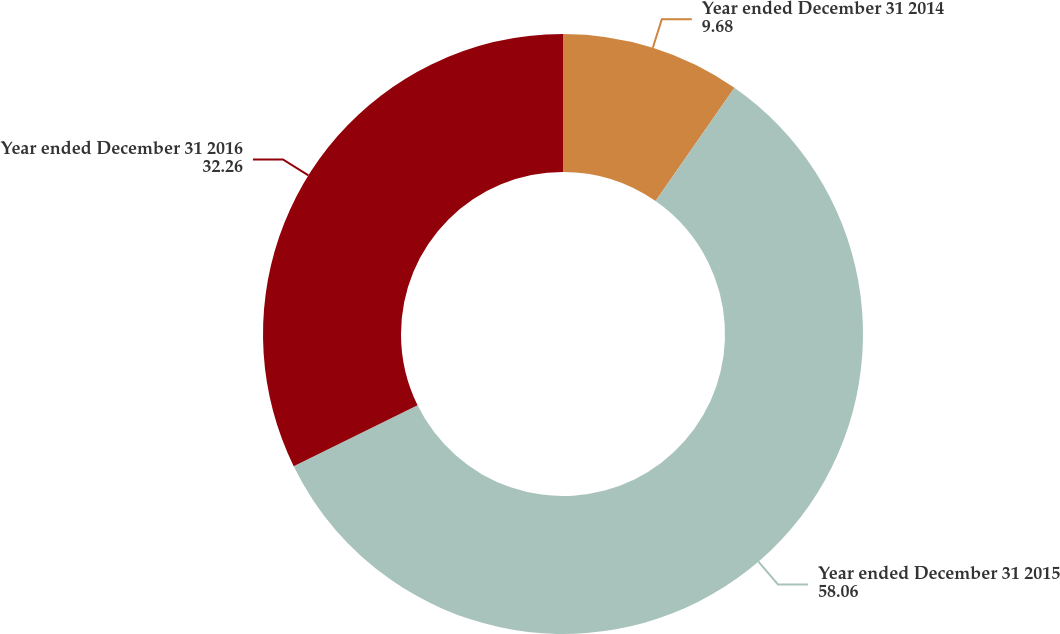<chart> <loc_0><loc_0><loc_500><loc_500><pie_chart><fcel>Year ended December 31 2014<fcel>Year ended December 31 2015<fcel>Year ended December 31 2016<nl><fcel>9.68%<fcel>58.06%<fcel>32.26%<nl></chart> 